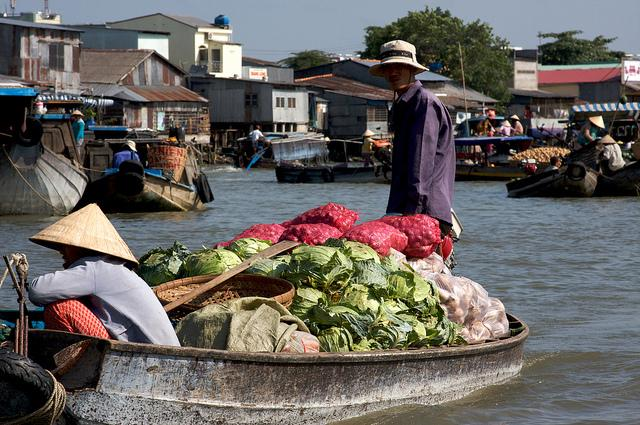What kind of boat is this? Please explain your reasoning. transport. A small boat has a person and a large amount of produce in it. 